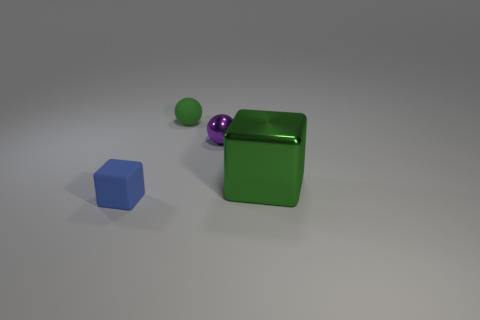How many cubes are the same color as the small matte ball?
Keep it short and to the point. 1. What material is the ball that is the same color as the large object?
Your answer should be very brief. Rubber. What is the size of the purple object that is the same material as the green block?
Keep it short and to the point. Small. There is a thing that is in front of the small shiny object and to the left of the small purple metal ball; what is it made of?
Your answer should be compact. Rubber. How many green metal cubes have the same size as the blue block?
Your response must be concise. 0. There is another object that is the same shape as the purple thing; what is its material?
Keep it short and to the point. Rubber. What number of things are matte objects behind the small purple metal object or tiny green matte objects behind the green cube?
Your answer should be compact. 1. There is a big green thing; does it have the same shape as the tiny rubber thing in front of the small metal ball?
Your answer should be very brief. Yes. The green object on the left side of the block that is on the right side of the small matte thing that is behind the green cube is what shape?
Offer a very short reply. Sphere. How many other things are there of the same material as the small purple object?
Ensure brevity in your answer.  1. 